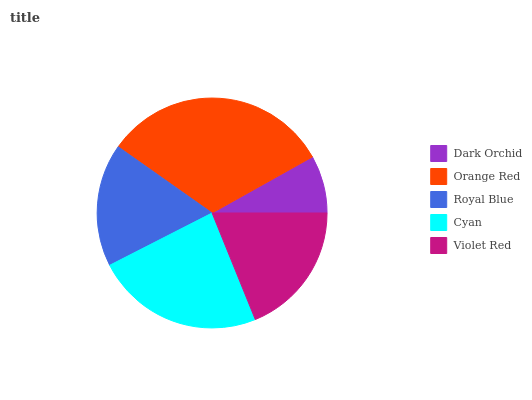Is Dark Orchid the minimum?
Answer yes or no. Yes. Is Orange Red the maximum?
Answer yes or no. Yes. Is Royal Blue the minimum?
Answer yes or no. No. Is Royal Blue the maximum?
Answer yes or no. No. Is Orange Red greater than Royal Blue?
Answer yes or no. Yes. Is Royal Blue less than Orange Red?
Answer yes or no. Yes. Is Royal Blue greater than Orange Red?
Answer yes or no. No. Is Orange Red less than Royal Blue?
Answer yes or no. No. Is Violet Red the high median?
Answer yes or no. Yes. Is Violet Red the low median?
Answer yes or no. Yes. Is Royal Blue the high median?
Answer yes or no. No. Is Dark Orchid the low median?
Answer yes or no. No. 